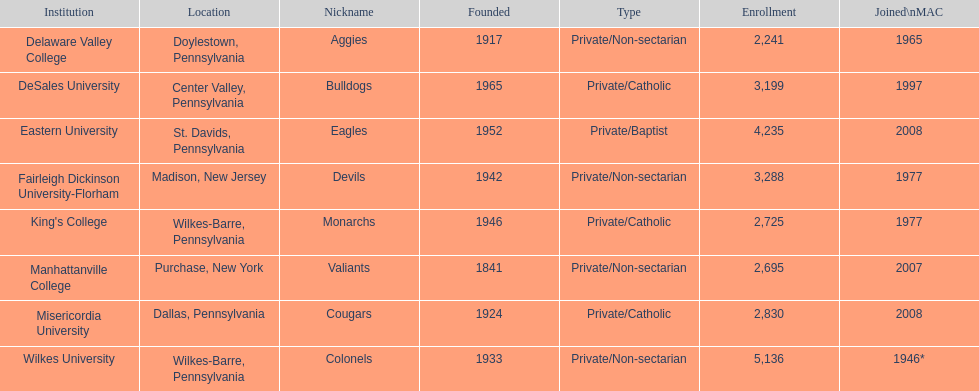What is the total enrollment in private/catholic educational establishments? 8,754. 